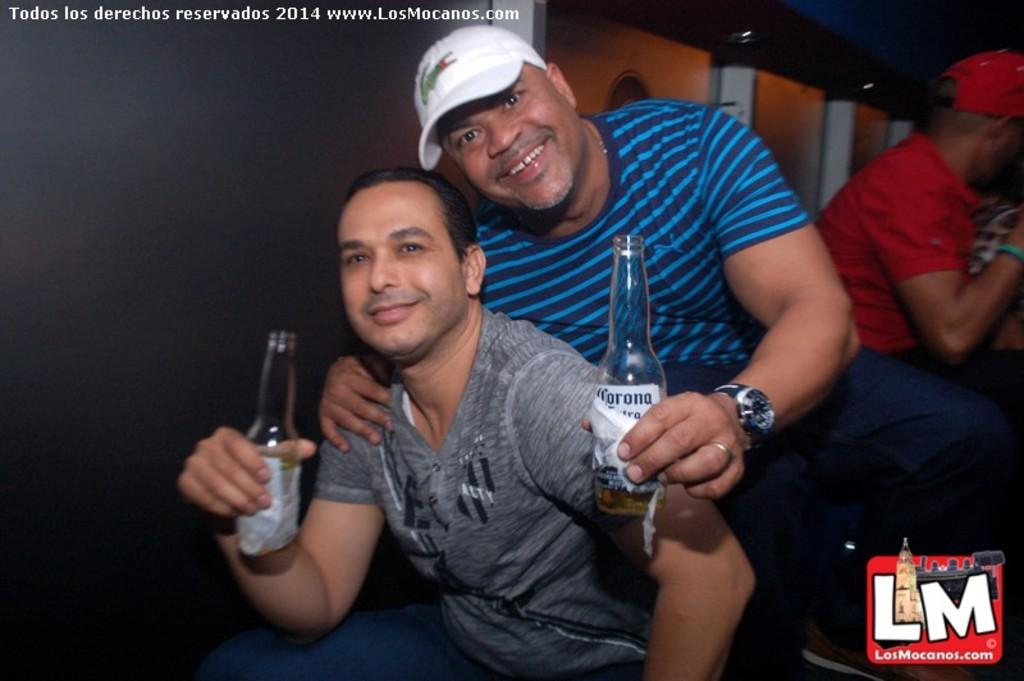How many people are in the image? There are two men in the image. What are the men holding in their hands? The men are holding wine bottles in their hands. Can you describe the person sitting in the image? There is a person sitting on the right side of the image. What type of pies are being recited by the men in the image? There are no pies or verses present in the image; the men are holding wine bottles. 